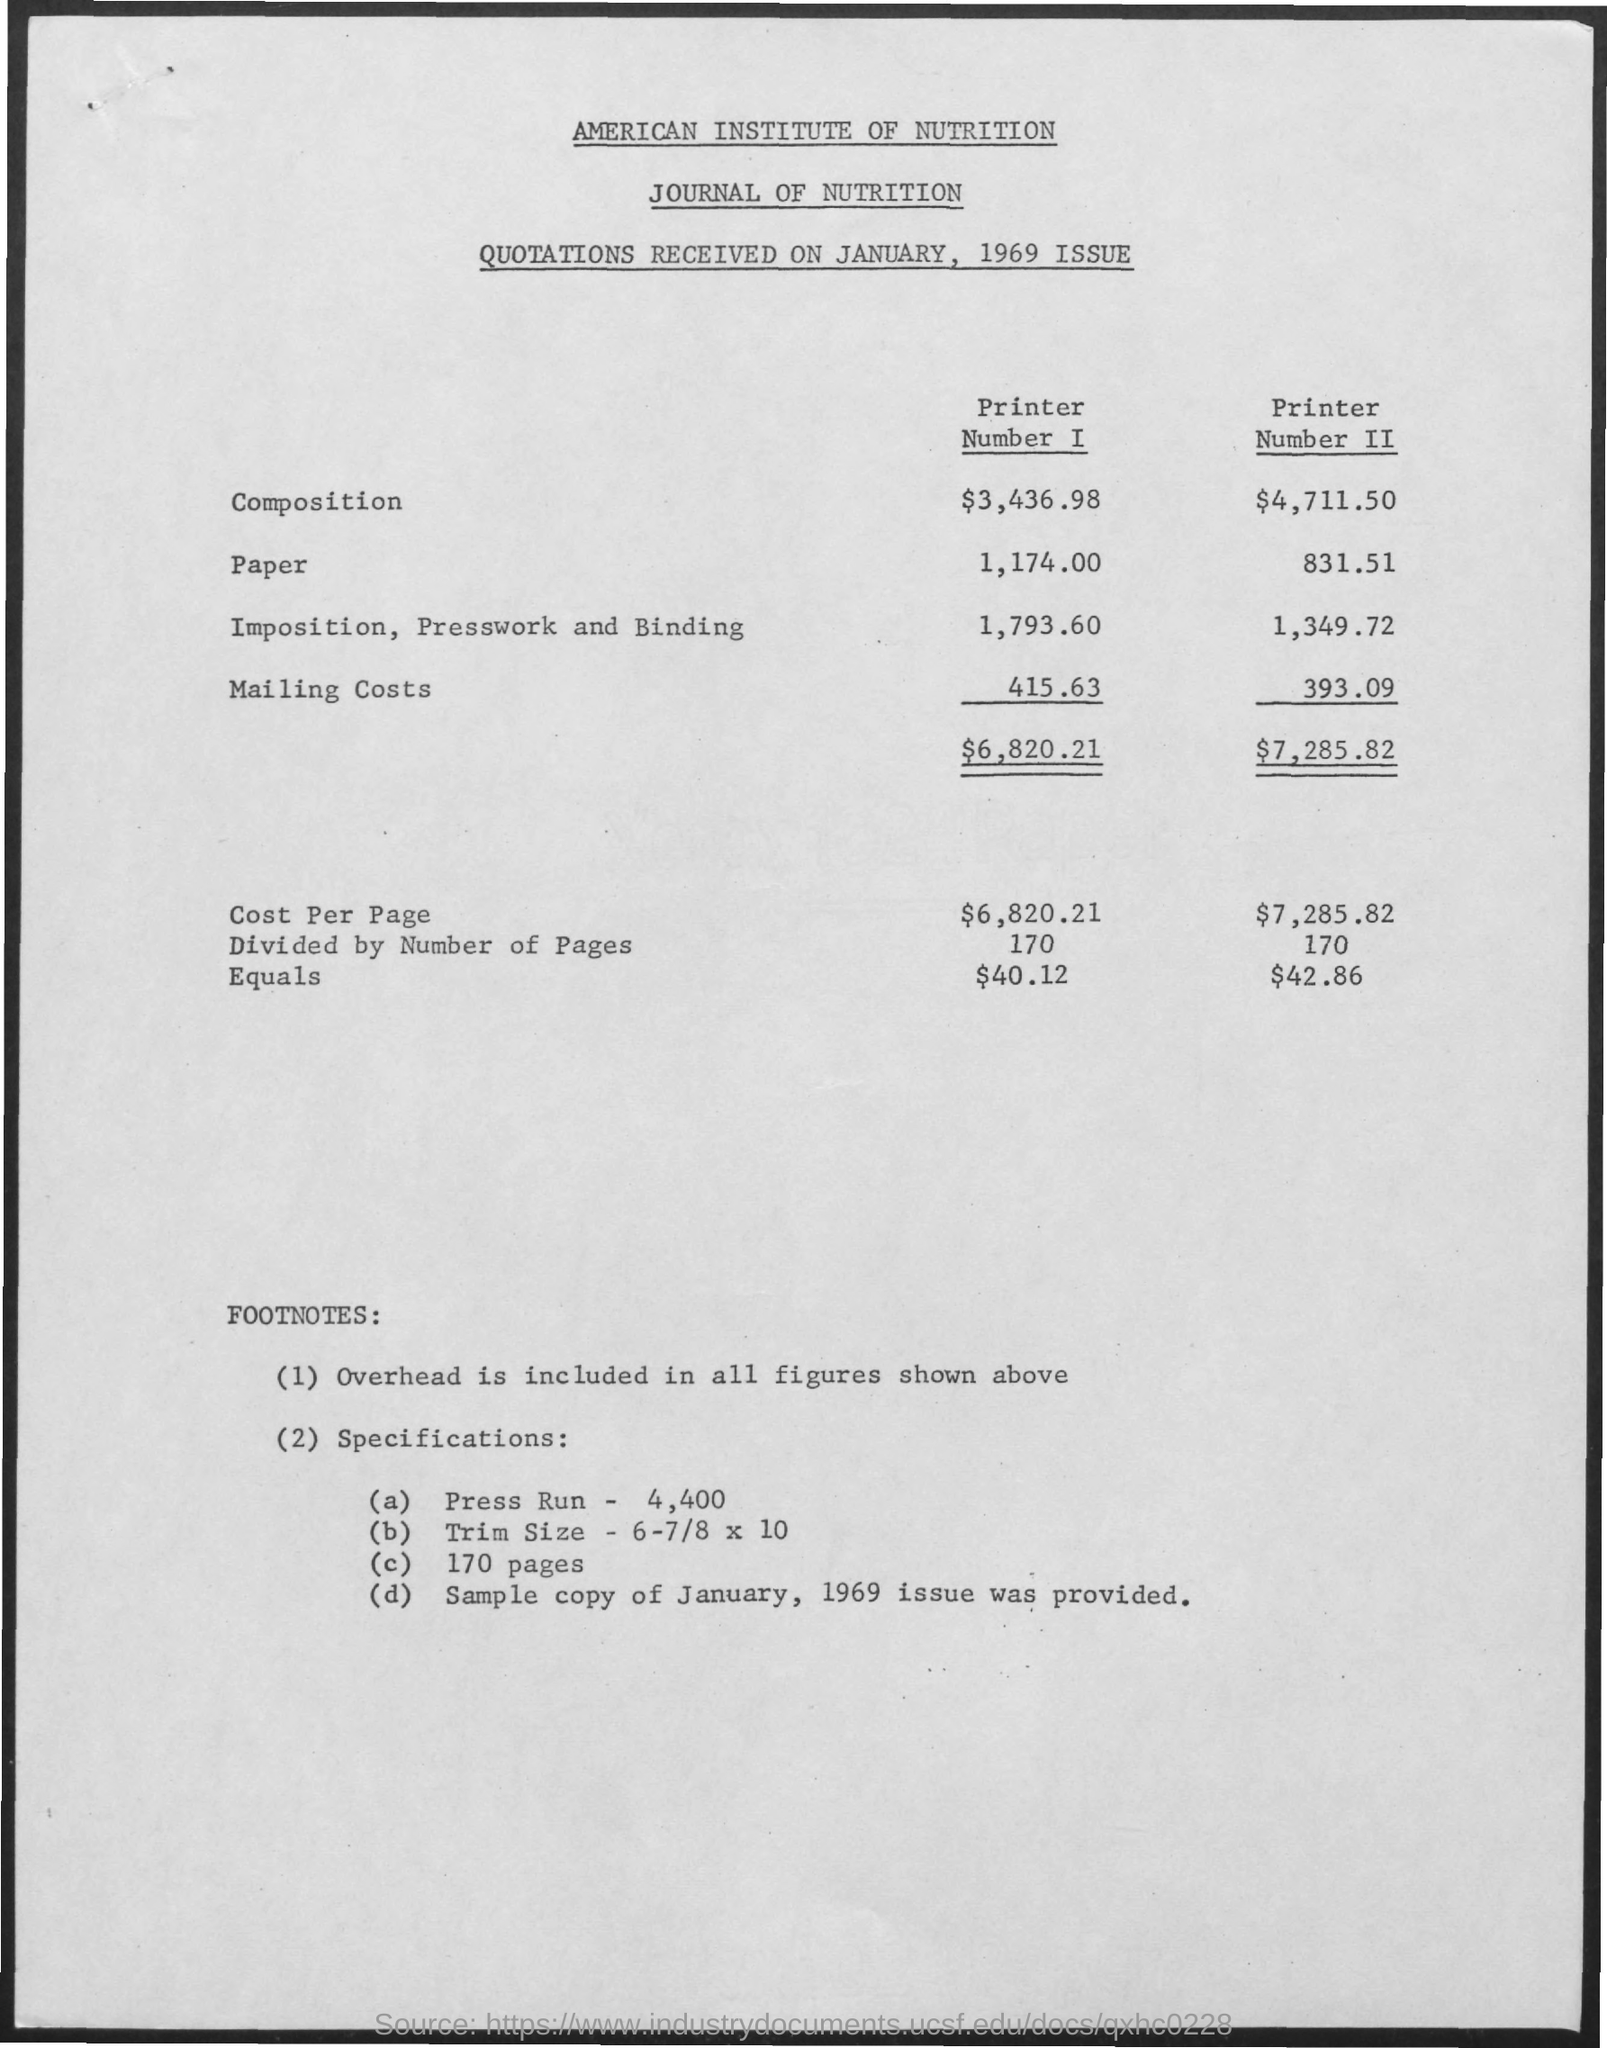What is amount of composition for printer number i ?
Offer a terse response. $ 3,436.98. What is the amount for composition for printer number ii ?
Your response must be concise. 4,711.50. What is the amount for paper for printer number i ?
Your answer should be compact. 1,174.00. What is the amount for paper for printer number ii?
Provide a short and direct response. 831.51. What is the amount for imposition, presswork and binding for printer number i ?
Offer a terse response. 1,793.60. What is the amount for imposition, presswork and binding for printer number ii ?
Give a very brief answer. $ 1,349.72. What is the cost per page for printer number i?
Provide a short and direct response. 6,820.21. What is cost per page for printer number ii ?
Make the answer very short. 7,285.82. What is the mailing costs for printer number i ?
Keep it short and to the point. $415.63. 